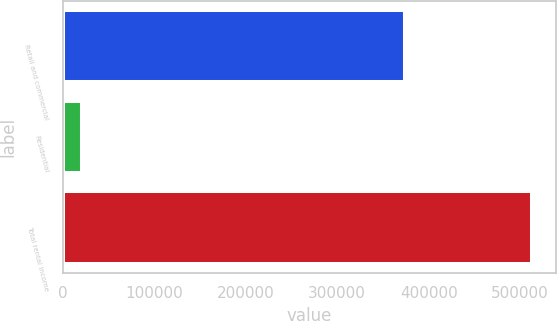<chart> <loc_0><loc_0><loc_500><loc_500><bar_chart><fcel>Retail and commercial<fcel>Residential<fcel>Total rental income<nl><fcel>373920<fcel>21093<fcel>513220<nl></chart> 